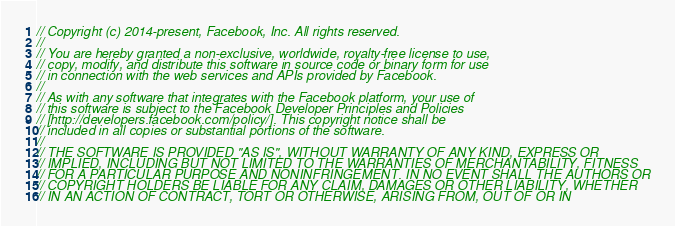Convert code to text. <code><loc_0><loc_0><loc_500><loc_500><_C_>// Copyright (c) 2014-present, Facebook, Inc. All rights reserved.
//
// You are hereby granted a non-exclusive, worldwide, royalty-free license to use,
// copy, modify, and distribute this software in source code or binary form for use
// in connection with the web services and APIs provided by Facebook.
//
// As with any software that integrates with the Facebook platform, your use of
// this software is subject to the Facebook Developer Principles and Policies
// [http://developers.facebook.com/policy/]. This copyright notice shall be
// included in all copies or substantial portions of the software.
//
// THE SOFTWARE IS PROVIDED "AS IS", WITHOUT WARRANTY OF ANY KIND, EXPRESS OR
// IMPLIED, INCLUDING BUT NOT LIMITED TO THE WARRANTIES OF MERCHANTABILITY, FITNESS
// FOR A PARTICULAR PURPOSE AND NONINFRINGEMENT. IN NO EVENT SHALL THE AUTHORS OR
// COPYRIGHT HOLDERS BE LIABLE FOR ANY CLAIM, DAMAGES OR OTHER LIABILITY, WHETHER
// IN AN ACTION OF CONTRACT, TORT OR OTHERWISE, ARISING FROM, OUT OF OR IN</code> 